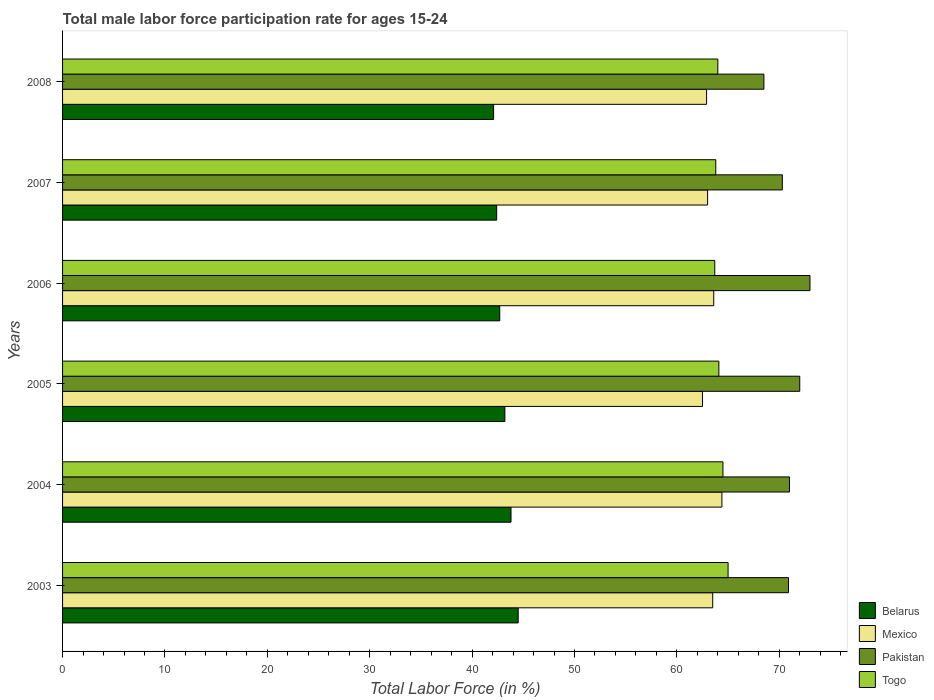Are the number of bars per tick equal to the number of legend labels?
Provide a succinct answer. Yes. In how many cases, is the number of bars for a given year not equal to the number of legend labels?
Your answer should be compact. 0. What is the male labor force participation rate in Pakistan in 2005?
Provide a succinct answer. 72. Across all years, what is the maximum male labor force participation rate in Belarus?
Keep it short and to the point. 44.5. Across all years, what is the minimum male labor force participation rate in Togo?
Offer a terse response. 63.7. In which year was the male labor force participation rate in Mexico minimum?
Your answer should be compact. 2005. What is the total male labor force participation rate in Pakistan in the graph?
Your answer should be very brief. 425.7. What is the difference between the male labor force participation rate in Pakistan in 2004 and that in 2007?
Offer a terse response. 0.7. What is the difference between the male labor force participation rate in Belarus in 2008 and the male labor force participation rate in Pakistan in 2007?
Keep it short and to the point. -28.2. What is the average male labor force participation rate in Pakistan per year?
Give a very brief answer. 70.95. In the year 2007, what is the difference between the male labor force participation rate in Togo and male labor force participation rate in Belarus?
Make the answer very short. 21.4. In how many years, is the male labor force participation rate in Mexico greater than 44 %?
Ensure brevity in your answer.  6. What is the ratio of the male labor force participation rate in Belarus in 2004 to that in 2007?
Provide a succinct answer. 1.03. Is the male labor force participation rate in Pakistan in 2006 less than that in 2007?
Offer a very short reply. No. Is the difference between the male labor force participation rate in Togo in 2003 and 2006 greater than the difference between the male labor force participation rate in Belarus in 2003 and 2006?
Offer a very short reply. No. What is the difference between the highest and the second highest male labor force participation rate in Mexico?
Offer a terse response. 0.8. What is the difference between the highest and the lowest male labor force participation rate in Mexico?
Make the answer very short. 1.9. What does the 2nd bar from the top in 2006 represents?
Keep it short and to the point. Pakistan. What does the 3rd bar from the bottom in 2007 represents?
Your answer should be very brief. Pakistan. Does the graph contain any zero values?
Offer a terse response. No. Does the graph contain grids?
Ensure brevity in your answer.  No. What is the title of the graph?
Offer a terse response. Total male labor force participation rate for ages 15-24. Does "Central African Republic" appear as one of the legend labels in the graph?
Offer a terse response. No. What is the label or title of the X-axis?
Keep it short and to the point. Total Labor Force (in %). What is the label or title of the Y-axis?
Offer a very short reply. Years. What is the Total Labor Force (in %) in Belarus in 2003?
Ensure brevity in your answer.  44.5. What is the Total Labor Force (in %) in Mexico in 2003?
Offer a very short reply. 63.5. What is the Total Labor Force (in %) in Pakistan in 2003?
Give a very brief answer. 70.9. What is the Total Labor Force (in %) of Togo in 2003?
Make the answer very short. 65. What is the Total Labor Force (in %) in Belarus in 2004?
Your answer should be compact. 43.8. What is the Total Labor Force (in %) in Mexico in 2004?
Ensure brevity in your answer.  64.4. What is the Total Labor Force (in %) of Togo in 2004?
Your response must be concise. 64.5. What is the Total Labor Force (in %) of Belarus in 2005?
Keep it short and to the point. 43.2. What is the Total Labor Force (in %) in Mexico in 2005?
Offer a very short reply. 62.5. What is the Total Labor Force (in %) in Pakistan in 2005?
Give a very brief answer. 72. What is the Total Labor Force (in %) in Togo in 2005?
Offer a terse response. 64.1. What is the Total Labor Force (in %) of Belarus in 2006?
Provide a succinct answer. 42.7. What is the Total Labor Force (in %) in Mexico in 2006?
Give a very brief answer. 63.6. What is the Total Labor Force (in %) of Togo in 2006?
Your answer should be very brief. 63.7. What is the Total Labor Force (in %) in Belarus in 2007?
Provide a short and direct response. 42.4. What is the Total Labor Force (in %) in Mexico in 2007?
Provide a short and direct response. 63. What is the Total Labor Force (in %) in Pakistan in 2007?
Your answer should be compact. 70.3. What is the Total Labor Force (in %) of Togo in 2007?
Offer a terse response. 63.8. What is the Total Labor Force (in %) of Belarus in 2008?
Give a very brief answer. 42.1. What is the Total Labor Force (in %) in Mexico in 2008?
Offer a terse response. 62.9. What is the Total Labor Force (in %) of Pakistan in 2008?
Keep it short and to the point. 68.5. Across all years, what is the maximum Total Labor Force (in %) of Belarus?
Ensure brevity in your answer.  44.5. Across all years, what is the maximum Total Labor Force (in %) of Mexico?
Your answer should be compact. 64.4. Across all years, what is the maximum Total Labor Force (in %) of Pakistan?
Your response must be concise. 73. Across all years, what is the minimum Total Labor Force (in %) of Belarus?
Keep it short and to the point. 42.1. Across all years, what is the minimum Total Labor Force (in %) of Mexico?
Your response must be concise. 62.5. Across all years, what is the minimum Total Labor Force (in %) of Pakistan?
Offer a terse response. 68.5. Across all years, what is the minimum Total Labor Force (in %) of Togo?
Your answer should be compact. 63.7. What is the total Total Labor Force (in %) in Belarus in the graph?
Offer a terse response. 258.7. What is the total Total Labor Force (in %) in Mexico in the graph?
Provide a short and direct response. 379.9. What is the total Total Labor Force (in %) in Pakistan in the graph?
Offer a very short reply. 425.7. What is the total Total Labor Force (in %) in Togo in the graph?
Your answer should be very brief. 385.1. What is the difference between the Total Labor Force (in %) of Pakistan in 2003 and that in 2004?
Give a very brief answer. -0.1. What is the difference between the Total Labor Force (in %) in Belarus in 2003 and that in 2005?
Keep it short and to the point. 1.3. What is the difference between the Total Labor Force (in %) in Togo in 2003 and that in 2005?
Your response must be concise. 0.9. What is the difference between the Total Labor Force (in %) of Mexico in 2003 and that in 2006?
Provide a succinct answer. -0.1. What is the difference between the Total Labor Force (in %) in Pakistan in 2003 and that in 2006?
Keep it short and to the point. -2.1. What is the difference between the Total Labor Force (in %) of Togo in 2003 and that in 2006?
Provide a succinct answer. 1.3. What is the difference between the Total Labor Force (in %) in Belarus in 2003 and that in 2007?
Offer a very short reply. 2.1. What is the difference between the Total Labor Force (in %) of Mexico in 2003 and that in 2007?
Your answer should be compact. 0.5. What is the difference between the Total Labor Force (in %) of Pakistan in 2003 and that in 2007?
Your answer should be very brief. 0.6. What is the difference between the Total Labor Force (in %) of Belarus in 2003 and that in 2008?
Your answer should be compact. 2.4. What is the difference between the Total Labor Force (in %) of Mexico in 2003 and that in 2008?
Provide a succinct answer. 0.6. What is the difference between the Total Labor Force (in %) of Pakistan in 2003 and that in 2008?
Your answer should be compact. 2.4. What is the difference between the Total Labor Force (in %) in Pakistan in 2004 and that in 2005?
Offer a terse response. -1. What is the difference between the Total Labor Force (in %) in Belarus in 2004 and that in 2006?
Ensure brevity in your answer.  1.1. What is the difference between the Total Labor Force (in %) in Mexico in 2004 and that in 2006?
Keep it short and to the point. 0.8. What is the difference between the Total Labor Force (in %) of Pakistan in 2004 and that in 2006?
Your answer should be very brief. -2. What is the difference between the Total Labor Force (in %) of Belarus in 2004 and that in 2007?
Your answer should be compact. 1.4. What is the difference between the Total Labor Force (in %) of Mexico in 2004 and that in 2007?
Make the answer very short. 1.4. What is the difference between the Total Labor Force (in %) of Mexico in 2004 and that in 2008?
Keep it short and to the point. 1.5. What is the difference between the Total Labor Force (in %) of Togo in 2005 and that in 2006?
Ensure brevity in your answer.  0.4. What is the difference between the Total Labor Force (in %) in Pakistan in 2005 and that in 2007?
Offer a terse response. 1.7. What is the difference between the Total Labor Force (in %) of Belarus in 2006 and that in 2007?
Your answer should be compact. 0.3. What is the difference between the Total Labor Force (in %) in Togo in 2006 and that in 2007?
Your answer should be compact. -0.1. What is the difference between the Total Labor Force (in %) in Belarus in 2006 and that in 2008?
Your answer should be very brief. 0.6. What is the difference between the Total Labor Force (in %) of Mexico in 2006 and that in 2008?
Your answer should be compact. 0.7. What is the difference between the Total Labor Force (in %) in Pakistan in 2006 and that in 2008?
Your response must be concise. 4.5. What is the difference between the Total Labor Force (in %) in Togo in 2006 and that in 2008?
Provide a succinct answer. -0.3. What is the difference between the Total Labor Force (in %) in Belarus in 2007 and that in 2008?
Offer a terse response. 0.3. What is the difference between the Total Labor Force (in %) of Pakistan in 2007 and that in 2008?
Your answer should be compact. 1.8. What is the difference between the Total Labor Force (in %) in Togo in 2007 and that in 2008?
Provide a succinct answer. -0.2. What is the difference between the Total Labor Force (in %) of Belarus in 2003 and the Total Labor Force (in %) of Mexico in 2004?
Keep it short and to the point. -19.9. What is the difference between the Total Labor Force (in %) in Belarus in 2003 and the Total Labor Force (in %) in Pakistan in 2004?
Make the answer very short. -26.5. What is the difference between the Total Labor Force (in %) in Mexico in 2003 and the Total Labor Force (in %) in Pakistan in 2004?
Offer a terse response. -7.5. What is the difference between the Total Labor Force (in %) in Mexico in 2003 and the Total Labor Force (in %) in Togo in 2004?
Offer a terse response. -1. What is the difference between the Total Labor Force (in %) of Pakistan in 2003 and the Total Labor Force (in %) of Togo in 2004?
Offer a very short reply. 6.4. What is the difference between the Total Labor Force (in %) in Belarus in 2003 and the Total Labor Force (in %) in Pakistan in 2005?
Your answer should be very brief. -27.5. What is the difference between the Total Labor Force (in %) in Belarus in 2003 and the Total Labor Force (in %) in Togo in 2005?
Give a very brief answer. -19.6. What is the difference between the Total Labor Force (in %) in Mexico in 2003 and the Total Labor Force (in %) in Pakistan in 2005?
Your answer should be compact. -8.5. What is the difference between the Total Labor Force (in %) of Pakistan in 2003 and the Total Labor Force (in %) of Togo in 2005?
Your answer should be compact. 6.8. What is the difference between the Total Labor Force (in %) in Belarus in 2003 and the Total Labor Force (in %) in Mexico in 2006?
Provide a short and direct response. -19.1. What is the difference between the Total Labor Force (in %) in Belarus in 2003 and the Total Labor Force (in %) in Pakistan in 2006?
Your answer should be very brief. -28.5. What is the difference between the Total Labor Force (in %) in Belarus in 2003 and the Total Labor Force (in %) in Togo in 2006?
Keep it short and to the point. -19.2. What is the difference between the Total Labor Force (in %) of Mexico in 2003 and the Total Labor Force (in %) of Togo in 2006?
Offer a very short reply. -0.2. What is the difference between the Total Labor Force (in %) in Pakistan in 2003 and the Total Labor Force (in %) in Togo in 2006?
Your answer should be very brief. 7.2. What is the difference between the Total Labor Force (in %) in Belarus in 2003 and the Total Labor Force (in %) in Mexico in 2007?
Your answer should be compact. -18.5. What is the difference between the Total Labor Force (in %) of Belarus in 2003 and the Total Labor Force (in %) of Pakistan in 2007?
Your answer should be very brief. -25.8. What is the difference between the Total Labor Force (in %) in Belarus in 2003 and the Total Labor Force (in %) in Togo in 2007?
Offer a terse response. -19.3. What is the difference between the Total Labor Force (in %) in Mexico in 2003 and the Total Labor Force (in %) in Pakistan in 2007?
Provide a short and direct response. -6.8. What is the difference between the Total Labor Force (in %) in Belarus in 2003 and the Total Labor Force (in %) in Mexico in 2008?
Make the answer very short. -18.4. What is the difference between the Total Labor Force (in %) of Belarus in 2003 and the Total Labor Force (in %) of Pakistan in 2008?
Your answer should be compact. -24. What is the difference between the Total Labor Force (in %) of Belarus in 2003 and the Total Labor Force (in %) of Togo in 2008?
Your answer should be very brief. -19.5. What is the difference between the Total Labor Force (in %) of Mexico in 2003 and the Total Labor Force (in %) of Pakistan in 2008?
Your answer should be very brief. -5. What is the difference between the Total Labor Force (in %) in Mexico in 2003 and the Total Labor Force (in %) in Togo in 2008?
Your response must be concise. -0.5. What is the difference between the Total Labor Force (in %) in Pakistan in 2003 and the Total Labor Force (in %) in Togo in 2008?
Your answer should be very brief. 6.9. What is the difference between the Total Labor Force (in %) of Belarus in 2004 and the Total Labor Force (in %) of Mexico in 2005?
Keep it short and to the point. -18.7. What is the difference between the Total Labor Force (in %) of Belarus in 2004 and the Total Labor Force (in %) of Pakistan in 2005?
Give a very brief answer. -28.2. What is the difference between the Total Labor Force (in %) in Belarus in 2004 and the Total Labor Force (in %) in Togo in 2005?
Keep it short and to the point. -20.3. What is the difference between the Total Labor Force (in %) in Mexico in 2004 and the Total Labor Force (in %) in Togo in 2005?
Your answer should be very brief. 0.3. What is the difference between the Total Labor Force (in %) of Belarus in 2004 and the Total Labor Force (in %) of Mexico in 2006?
Ensure brevity in your answer.  -19.8. What is the difference between the Total Labor Force (in %) in Belarus in 2004 and the Total Labor Force (in %) in Pakistan in 2006?
Make the answer very short. -29.2. What is the difference between the Total Labor Force (in %) in Belarus in 2004 and the Total Labor Force (in %) in Togo in 2006?
Your answer should be compact. -19.9. What is the difference between the Total Labor Force (in %) in Mexico in 2004 and the Total Labor Force (in %) in Pakistan in 2006?
Provide a short and direct response. -8.6. What is the difference between the Total Labor Force (in %) of Mexico in 2004 and the Total Labor Force (in %) of Togo in 2006?
Ensure brevity in your answer.  0.7. What is the difference between the Total Labor Force (in %) of Pakistan in 2004 and the Total Labor Force (in %) of Togo in 2006?
Offer a very short reply. 7.3. What is the difference between the Total Labor Force (in %) of Belarus in 2004 and the Total Labor Force (in %) of Mexico in 2007?
Keep it short and to the point. -19.2. What is the difference between the Total Labor Force (in %) in Belarus in 2004 and the Total Labor Force (in %) in Pakistan in 2007?
Your response must be concise. -26.5. What is the difference between the Total Labor Force (in %) of Mexico in 2004 and the Total Labor Force (in %) of Pakistan in 2007?
Ensure brevity in your answer.  -5.9. What is the difference between the Total Labor Force (in %) of Pakistan in 2004 and the Total Labor Force (in %) of Togo in 2007?
Your response must be concise. 7.2. What is the difference between the Total Labor Force (in %) in Belarus in 2004 and the Total Labor Force (in %) in Mexico in 2008?
Give a very brief answer. -19.1. What is the difference between the Total Labor Force (in %) of Belarus in 2004 and the Total Labor Force (in %) of Pakistan in 2008?
Offer a terse response. -24.7. What is the difference between the Total Labor Force (in %) in Belarus in 2004 and the Total Labor Force (in %) in Togo in 2008?
Your answer should be very brief. -20.2. What is the difference between the Total Labor Force (in %) in Mexico in 2004 and the Total Labor Force (in %) in Togo in 2008?
Provide a succinct answer. 0.4. What is the difference between the Total Labor Force (in %) of Belarus in 2005 and the Total Labor Force (in %) of Mexico in 2006?
Offer a terse response. -20.4. What is the difference between the Total Labor Force (in %) of Belarus in 2005 and the Total Labor Force (in %) of Pakistan in 2006?
Offer a very short reply. -29.8. What is the difference between the Total Labor Force (in %) of Belarus in 2005 and the Total Labor Force (in %) of Togo in 2006?
Keep it short and to the point. -20.5. What is the difference between the Total Labor Force (in %) of Mexico in 2005 and the Total Labor Force (in %) of Togo in 2006?
Your answer should be compact. -1.2. What is the difference between the Total Labor Force (in %) of Pakistan in 2005 and the Total Labor Force (in %) of Togo in 2006?
Give a very brief answer. 8.3. What is the difference between the Total Labor Force (in %) in Belarus in 2005 and the Total Labor Force (in %) in Mexico in 2007?
Your response must be concise. -19.8. What is the difference between the Total Labor Force (in %) in Belarus in 2005 and the Total Labor Force (in %) in Pakistan in 2007?
Your answer should be compact. -27.1. What is the difference between the Total Labor Force (in %) in Belarus in 2005 and the Total Labor Force (in %) in Togo in 2007?
Provide a short and direct response. -20.6. What is the difference between the Total Labor Force (in %) of Mexico in 2005 and the Total Labor Force (in %) of Pakistan in 2007?
Keep it short and to the point. -7.8. What is the difference between the Total Labor Force (in %) of Belarus in 2005 and the Total Labor Force (in %) of Mexico in 2008?
Offer a very short reply. -19.7. What is the difference between the Total Labor Force (in %) of Belarus in 2005 and the Total Labor Force (in %) of Pakistan in 2008?
Offer a terse response. -25.3. What is the difference between the Total Labor Force (in %) in Belarus in 2005 and the Total Labor Force (in %) in Togo in 2008?
Keep it short and to the point. -20.8. What is the difference between the Total Labor Force (in %) of Pakistan in 2005 and the Total Labor Force (in %) of Togo in 2008?
Ensure brevity in your answer.  8. What is the difference between the Total Labor Force (in %) in Belarus in 2006 and the Total Labor Force (in %) in Mexico in 2007?
Offer a terse response. -20.3. What is the difference between the Total Labor Force (in %) of Belarus in 2006 and the Total Labor Force (in %) of Pakistan in 2007?
Offer a very short reply. -27.6. What is the difference between the Total Labor Force (in %) in Belarus in 2006 and the Total Labor Force (in %) in Togo in 2007?
Keep it short and to the point. -21.1. What is the difference between the Total Labor Force (in %) of Pakistan in 2006 and the Total Labor Force (in %) of Togo in 2007?
Offer a terse response. 9.2. What is the difference between the Total Labor Force (in %) in Belarus in 2006 and the Total Labor Force (in %) in Mexico in 2008?
Provide a succinct answer. -20.2. What is the difference between the Total Labor Force (in %) in Belarus in 2006 and the Total Labor Force (in %) in Pakistan in 2008?
Make the answer very short. -25.8. What is the difference between the Total Labor Force (in %) in Belarus in 2006 and the Total Labor Force (in %) in Togo in 2008?
Your response must be concise. -21.3. What is the difference between the Total Labor Force (in %) in Mexico in 2006 and the Total Labor Force (in %) in Pakistan in 2008?
Offer a very short reply. -4.9. What is the difference between the Total Labor Force (in %) in Belarus in 2007 and the Total Labor Force (in %) in Mexico in 2008?
Your answer should be very brief. -20.5. What is the difference between the Total Labor Force (in %) in Belarus in 2007 and the Total Labor Force (in %) in Pakistan in 2008?
Provide a short and direct response. -26.1. What is the difference between the Total Labor Force (in %) of Belarus in 2007 and the Total Labor Force (in %) of Togo in 2008?
Provide a short and direct response. -21.6. What is the difference between the Total Labor Force (in %) in Mexico in 2007 and the Total Labor Force (in %) in Pakistan in 2008?
Ensure brevity in your answer.  -5.5. What is the average Total Labor Force (in %) in Belarus per year?
Give a very brief answer. 43.12. What is the average Total Labor Force (in %) in Mexico per year?
Your answer should be very brief. 63.32. What is the average Total Labor Force (in %) of Pakistan per year?
Keep it short and to the point. 70.95. What is the average Total Labor Force (in %) of Togo per year?
Offer a very short reply. 64.18. In the year 2003, what is the difference between the Total Labor Force (in %) in Belarus and Total Labor Force (in %) in Mexico?
Give a very brief answer. -19. In the year 2003, what is the difference between the Total Labor Force (in %) in Belarus and Total Labor Force (in %) in Pakistan?
Your answer should be compact. -26.4. In the year 2003, what is the difference between the Total Labor Force (in %) of Belarus and Total Labor Force (in %) of Togo?
Provide a short and direct response. -20.5. In the year 2003, what is the difference between the Total Labor Force (in %) in Mexico and Total Labor Force (in %) in Pakistan?
Offer a very short reply. -7.4. In the year 2003, what is the difference between the Total Labor Force (in %) in Mexico and Total Labor Force (in %) in Togo?
Ensure brevity in your answer.  -1.5. In the year 2004, what is the difference between the Total Labor Force (in %) in Belarus and Total Labor Force (in %) in Mexico?
Your answer should be very brief. -20.6. In the year 2004, what is the difference between the Total Labor Force (in %) in Belarus and Total Labor Force (in %) in Pakistan?
Keep it short and to the point. -27.2. In the year 2004, what is the difference between the Total Labor Force (in %) of Belarus and Total Labor Force (in %) of Togo?
Offer a very short reply. -20.7. In the year 2004, what is the difference between the Total Labor Force (in %) of Mexico and Total Labor Force (in %) of Pakistan?
Your response must be concise. -6.6. In the year 2004, what is the difference between the Total Labor Force (in %) in Pakistan and Total Labor Force (in %) in Togo?
Provide a succinct answer. 6.5. In the year 2005, what is the difference between the Total Labor Force (in %) of Belarus and Total Labor Force (in %) of Mexico?
Make the answer very short. -19.3. In the year 2005, what is the difference between the Total Labor Force (in %) of Belarus and Total Labor Force (in %) of Pakistan?
Your response must be concise. -28.8. In the year 2005, what is the difference between the Total Labor Force (in %) in Belarus and Total Labor Force (in %) in Togo?
Provide a succinct answer. -20.9. In the year 2005, what is the difference between the Total Labor Force (in %) of Mexico and Total Labor Force (in %) of Pakistan?
Keep it short and to the point. -9.5. In the year 2005, what is the difference between the Total Labor Force (in %) in Pakistan and Total Labor Force (in %) in Togo?
Provide a short and direct response. 7.9. In the year 2006, what is the difference between the Total Labor Force (in %) in Belarus and Total Labor Force (in %) in Mexico?
Offer a terse response. -20.9. In the year 2006, what is the difference between the Total Labor Force (in %) of Belarus and Total Labor Force (in %) of Pakistan?
Make the answer very short. -30.3. In the year 2006, what is the difference between the Total Labor Force (in %) in Mexico and Total Labor Force (in %) in Pakistan?
Make the answer very short. -9.4. In the year 2006, what is the difference between the Total Labor Force (in %) in Pakistan and Total Labor Force (in %) in Togo?
Provide a succinct answer. 9.3. In the year 2007, what is the difference between the Total Labor Force (in %) of Belarus and Total Labor Force (in %) of Mexico?
Offer a terse response. -20.6. In the year 2007, what is the difference between the Total Labor Force (in %) of Belarus and Total Labor Force (in %) of Pakistan?
Your answer should be very brief. -27.9. In the year 2007, what is the difference between the Total Labor Force (in %) in Belarus and Total Labor Force (in %) in Togo?
Provide a succinct answer. -21.4. In the year 2007, what is the difference between the Total Labor Force (in %) of Mexico and Total Labor Force (in %) of Pakistan?
Make the answer very short. -7.3. In the year 2007, what is the difference between the Total Labor Force (in %) in Mexico and Total Labor Force (in %) in Togo?
Make the answer very short. -0.8. In the year 2007, what is the difference between the Total Labor Force (in %) in Pakistan and Total Labor Force (in %) in Togo?
Keep it short and to the point. 6.5. In the year 2008, what is the difference between the Total Labor Force (in %) in Belarus and Total Labor Force (in %) in Mexico?
Ensure brevity in your answer.  -20.8. In the year 2008, what is the difference between the Total Labor Force (in %) of Belarus and Total Labor Force (in %) of Pakistan?
Ensure brevity in your answer.  -26.4. In the year 2008, what is the difference between the Total Labor Force (in %) of Belarus and Total Labor Force (in %) of Togo?
Offer a very short reply. -21.9. In the year 2008, what is the difference between the Total Labor Force (in %) in Mexico and Total Labor Force (in %) in Togo?
Make the answer very short. -1.1. What is the ratio of the Total Labor Force (in %) of Belarus in 2003 to that in 2004?
Give a very brief answer. 1.02. What is the ratio of the Total Labor Force (in %) in Mexico in 2003 to that in 2004?
Provide a short and direct response. 0.99. What is the ratio of the Total Labor Force (in %) of Pakistan in 2003 to that in 2004?
Offer a terse response. 1. What is the ratio of the Total Labor Force (in %) of Belarus in 2003 to that in 2005?
Give a very brief answer. 1.03. What is the ratio of the Total Labor Force (in %) of Mexico in 2003 to that in 2005?
Make the answer very short. 1.02. What is the ratio of the Total Labor Force (in %) in Pakistan in 2003 to that in 2005?
Provide a succinct answer. 0.98. What is the ratio of the Total Labor Force (in %) in Togo in 2003 to that in 2005?
Ensure brevity in your answer.  1.01. What is the ratio of the Total Labor Force (in %) in Belarus in 2003 to that in 2006?
Offer a terse response. 1.04. What is the ratio of the Total Labor Force (in %) of Pakistan in 2003 to that in 2006?
Offer a terse response. 0.97. What is the ratio of the Total Labor Force (in %) of Togo in 2003 to that in 2006?
Your response must be concise. 1.02. What is the ratio of the Total Labor Force (in %) of Belarus in 2003 to that in 2007?
Offer a very short reply. 1.05. What is the ratio of the Total Labor Force (in %) in Mexico in 2003 to that in 2007?
Your answer should be compact. 1.01. What is the ratio of the Total Labor Force (in %) in Pakistan in 2003 to that in 2007?
Ensure brevity in your answer.  1.01. What is the ratio of the Total Labor Force (in %) of Togo in 2003 to that in 2007?
Provide a succinct answer. 1.02. What is the ratio of the Total Labor Force (in %) in Belarus in 2003 to that in 2008?
Ensure brevity in your answer.  1.06. What is the ratio of the Total Labor Force (in %) of Mexico in 2003 to that in 2008?
Your response must be concise. 1.01. What is the ratio of the Total Labor Force (in %) of Pakistan in 2003 to that in 2008?
Provide a succinct answer. 1.03. What is the ratio of the Total Labor Force (in %) of Togo in 2003 to that in 2008?
Your answer should be very brief. 1.02. What is the ratio of the Total Labor Force (in %) in Belarus in 2004 to that in 2005?
Your response must be concise. 1.01. What is the ratio of the Total Labor Force (in %) in Mexico in 2004 to that in 2005?
Give a very brief answer. 1.03. What is the ratio of the Total Labor Force (in %) in Pakistan in 2004 to that in 2005?
Give a very brief answer. 0.99. What is the ratio of the Total Labor Force (in %) in Togo in 2004 to that in 2005?
Offer a very short reply. 1.01. What is the ratio of the Total Labor Force (in %) in Belarus in 2004 to that in 2006?
Give a very brief answer. 1.03. What is the ratio of the Total Labor Force (in %) in Mexico in 2004 to that in 2006?
Ensure brevity in your answer.  1.01. What is the ratio of the Total Labor Force (in %) in Pakistan in 2004 to that in 2006?
Your answer should be very brief. 0.97. What is the ratio of the Total Labor Force (in %) of Togo in 2004 to that in 2006?
Keep it short and to the point. 1.01. What is the ratio of the Total Labor Force (in %) in Belarus in 2004 to that in 2007?
Your response must be concise. 1.03. What is the ratio of the Total Labor Force (in %) of Mexico in 2004 to that in 2007?
Offer a very short reply. 1.02. What is the ratio of the Total Labor Force (in %) of Belarus in 2004 to that in 2008?
Your response must be concise. 1.04. What is the ratio of the Total Labor Force (in %) of Mexico in 2004 to that in 2008?
Provide a short and direct response. 1.02. What is the ratio of the Total Labor Force (in %) in Pakistan in 2004 to that in 2008?
Make the answer very short. 1.04. What is the ratio of the Total Labor Force (in %) in Togo in 2004 to that in 2008?
Provide a short and direct response. 1.01. What is the ratio of the Total Labor Force (in %) in Belarus in 2005 to that in 2006?
Your answer should be very brief. 1.01. What is the ratio of the Total Labor Force (in %) in Mexico in 2005 to that in 2006?
Give a very brief answer. 0.98. What is the ratio of the Total Labor Force (in %) of Pakistan in 2005 to that in 2006?
Provide a succinct answer. 0.99. What is the ratio of the Total Labor Force (in %) of Togo in 2005 to that in 2006?
Your answer should be very brief. 1.01. What is the ratio of the Total Labor Force (in %) in Belarus in 2005 to that in 2007?
Keep it short and to the point. 1.02. What is the ratio of the Total Labor Force (in %) in Pakistan in 2005 to that in 2007?
Your answer should be very brief. 1.02. What is the ratio of the Total Labor Force (in %) in Togo in 2005 to that in 2007?
Your answer should be compact. 1. What is the ratio of the Total Labor Force (in %) in Belarus in 2005 to that in 2008?
Your answer should be compact. 1.03. What is the ratio of the Total Labor Force (in %) of Mexico in 2005 to that in 2008?
Your answer should be compact. 0.99. What is the ratio of the Total Labor Force (in %) of Pakistan in 2005 to that in 2008?
Make the answer very short. 1.05. What is the ratio of the Total Labor Force (in %) of Belarus in 2006 to that in 2007?
Provide a succinct answer. 1.01. What is the ratio of the Total Labor Force (in %) in Mexico in 2006 to that in 2007?
Provide a short and direct response. 1.01. What is the ratio of the Total Labor Force (in %) in Pakistan in 2006 to that in 2007?
Offer a very short reply. 1.04. What is the ratio of the Total Labor Force (in %) of Belarus in 2006 to that in 2008?
Ensure brevity in your answer.  1.01. What is the ratio of the Total Labor Force (in %) in Mexico in 2006 to that in 2008?
Make the answer very short. 1.01. What is the ratio of the Total Labor Force (in %) in Pakistan in 2006 to that in 2008?
Give a very brief answer. 1.07. What is the ratio of the Total Labor Force (in %) in Togo in 2006 to that in 2008?
Your answer should be very brief. 1. What is the ratio of the Total Labor Force (in %) of Belarus in 2007 to that in 2008?
Make the answer very short. 1.01. What is the ratio of the Total Labor Force (in %) of Mexico in 2007 to that in 2008?
Make the answer very short. 1. What is the ratio of the Total Labor Force (in %) of Pakistan in 2007 to that in 2008?
Your answer should be very brief. 1.03. What is the difference between the highest and the second highest Total Labor Force (in %) in Belarus?
Provide a short and direct response. 0.7. What is the difference between the highest and the second highest Total Labor Force (in %) of Togo?
Make the answer very short. 0.5. What is the difference between the highest and the lowest Total Labor Force (in %) in Mexico?
Your answer should be very brief. 1.9. What is the difference between the highest and the lowest Total Labor Force (in %) of Pakistan?
Your answer should be very brief. 4.5. What is the difference between the highest and the lowest Total Labor Force (in %) in Togo?
Your answer should be compact. 1.3. 